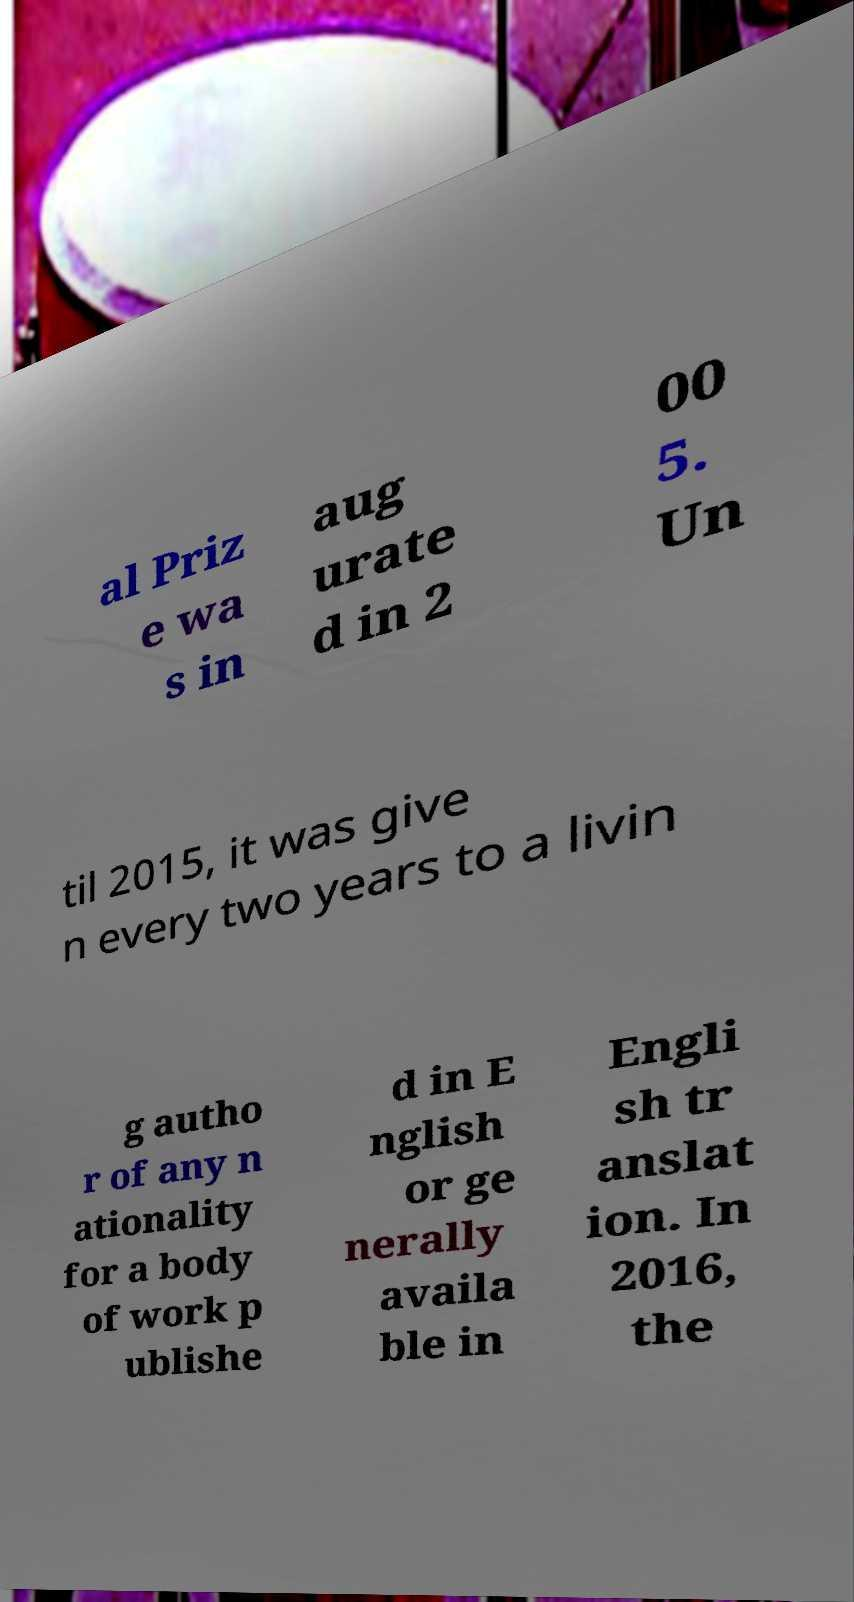Can you read and provide the text displayed in the image?This photo seems to have some interesting text. Can you extract and type it out for me? al Priz e wa s in aug urate d in 2 00 5. Un til 2015, it was give n every two years to a livin g autho r of any n ationality for a body of work p ublishe d in E nglish or ge nerally availa ble in Engli sh tr anslat ion. In 2016, the 